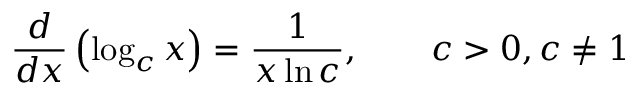Convert formula to latex. <formula><loc_0><loc_0><loc_500><loc_500>{ \frac { d } { d x } } \left ( \log _ { c } x \right ) = { \frac { 1 } { x \ln c } } , \quad c > 0 , c \neq 1</formula> 